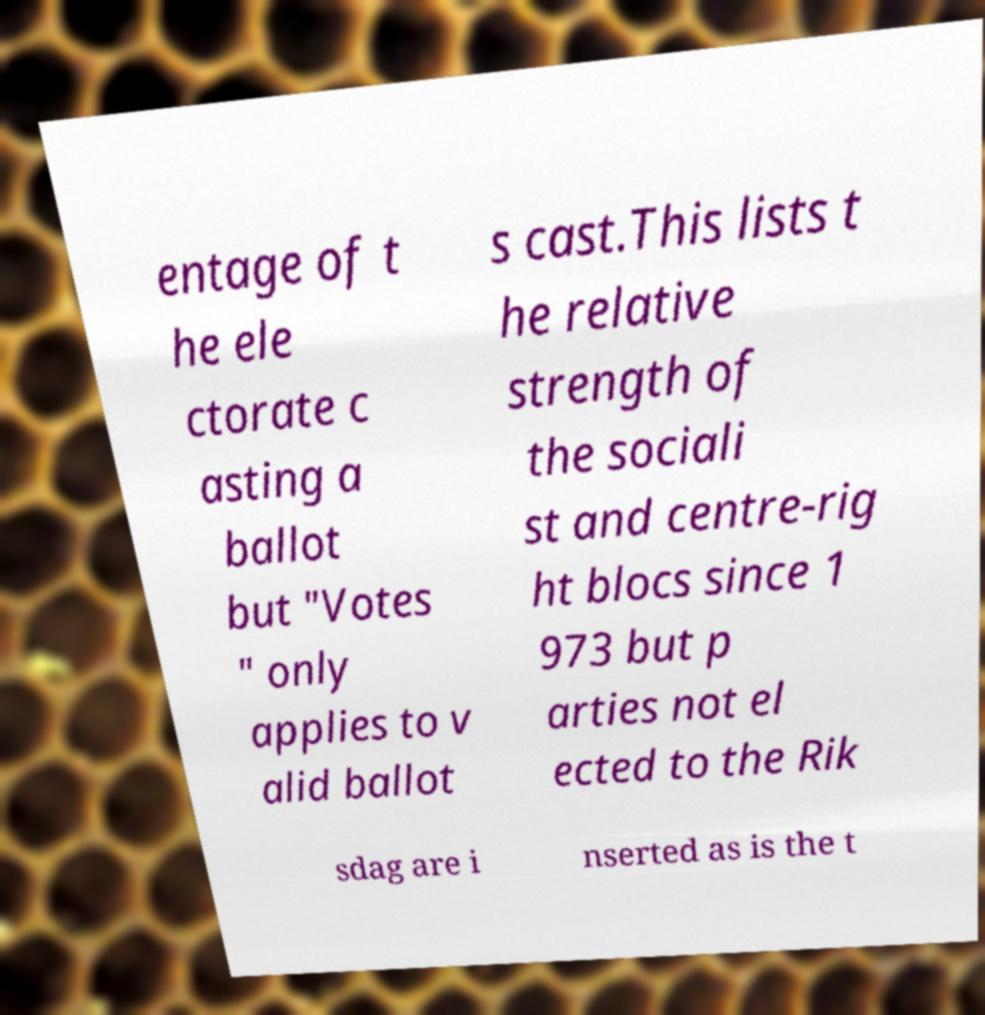Could you extract and type out the text from this image? entage of t he ele ctorate c asting a ballot but "Votes " only applies to v alid ballot s cast.This lists t he relative strength of the sociali st and centre-rig ht blocs since 1 973 but p arties not el ected to the Rik sdag are i nserted as is the t 